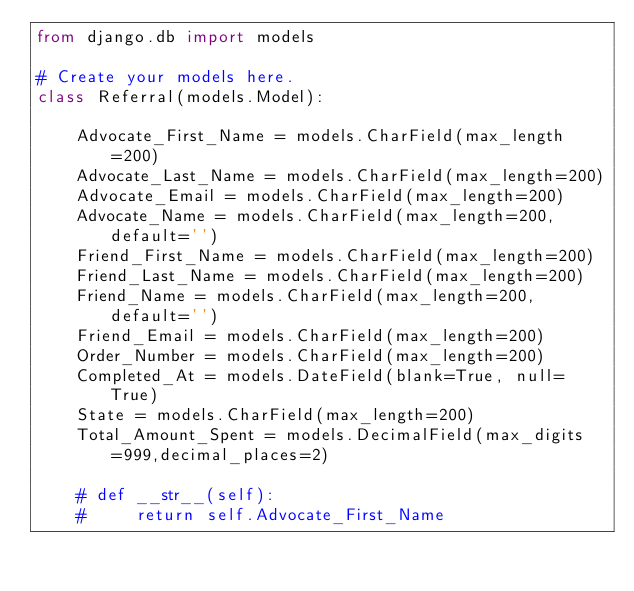<code> <loc_0><loc_0><loc_500><loc_500><_Python_>from django.db import models

# Create your models here.
class Referral(models.Model):

    Advocate_First_Name = models.CharField(max_length=200)
    Advocate_Last_Name = models.CharField(max_length=200)
    Advocate_Email = models.CharField(max_length=200)
    Advocate_Name = models.CharField(max_length=200, default='')
    Friend_First_Name = models.CharField(max_length=200)
    Friend_Last_Name = models.CharField(max_length=200)
    Friend_Name = models.CharField(max_length=200, default='')
    Friend_Email = models.CharField(max_length=200)
    Order_Number = models.CharField(max_length=200)
    Completed_At = models.DateField(blank=True, null= True)
    State = models.CharField(max_length=200)
    Total_Amount_Spent = models.DecimalField(max_digits=999,decimal_places=2)

    # def __str__(self):
    #     return self.Advocate_First_Name</code> 